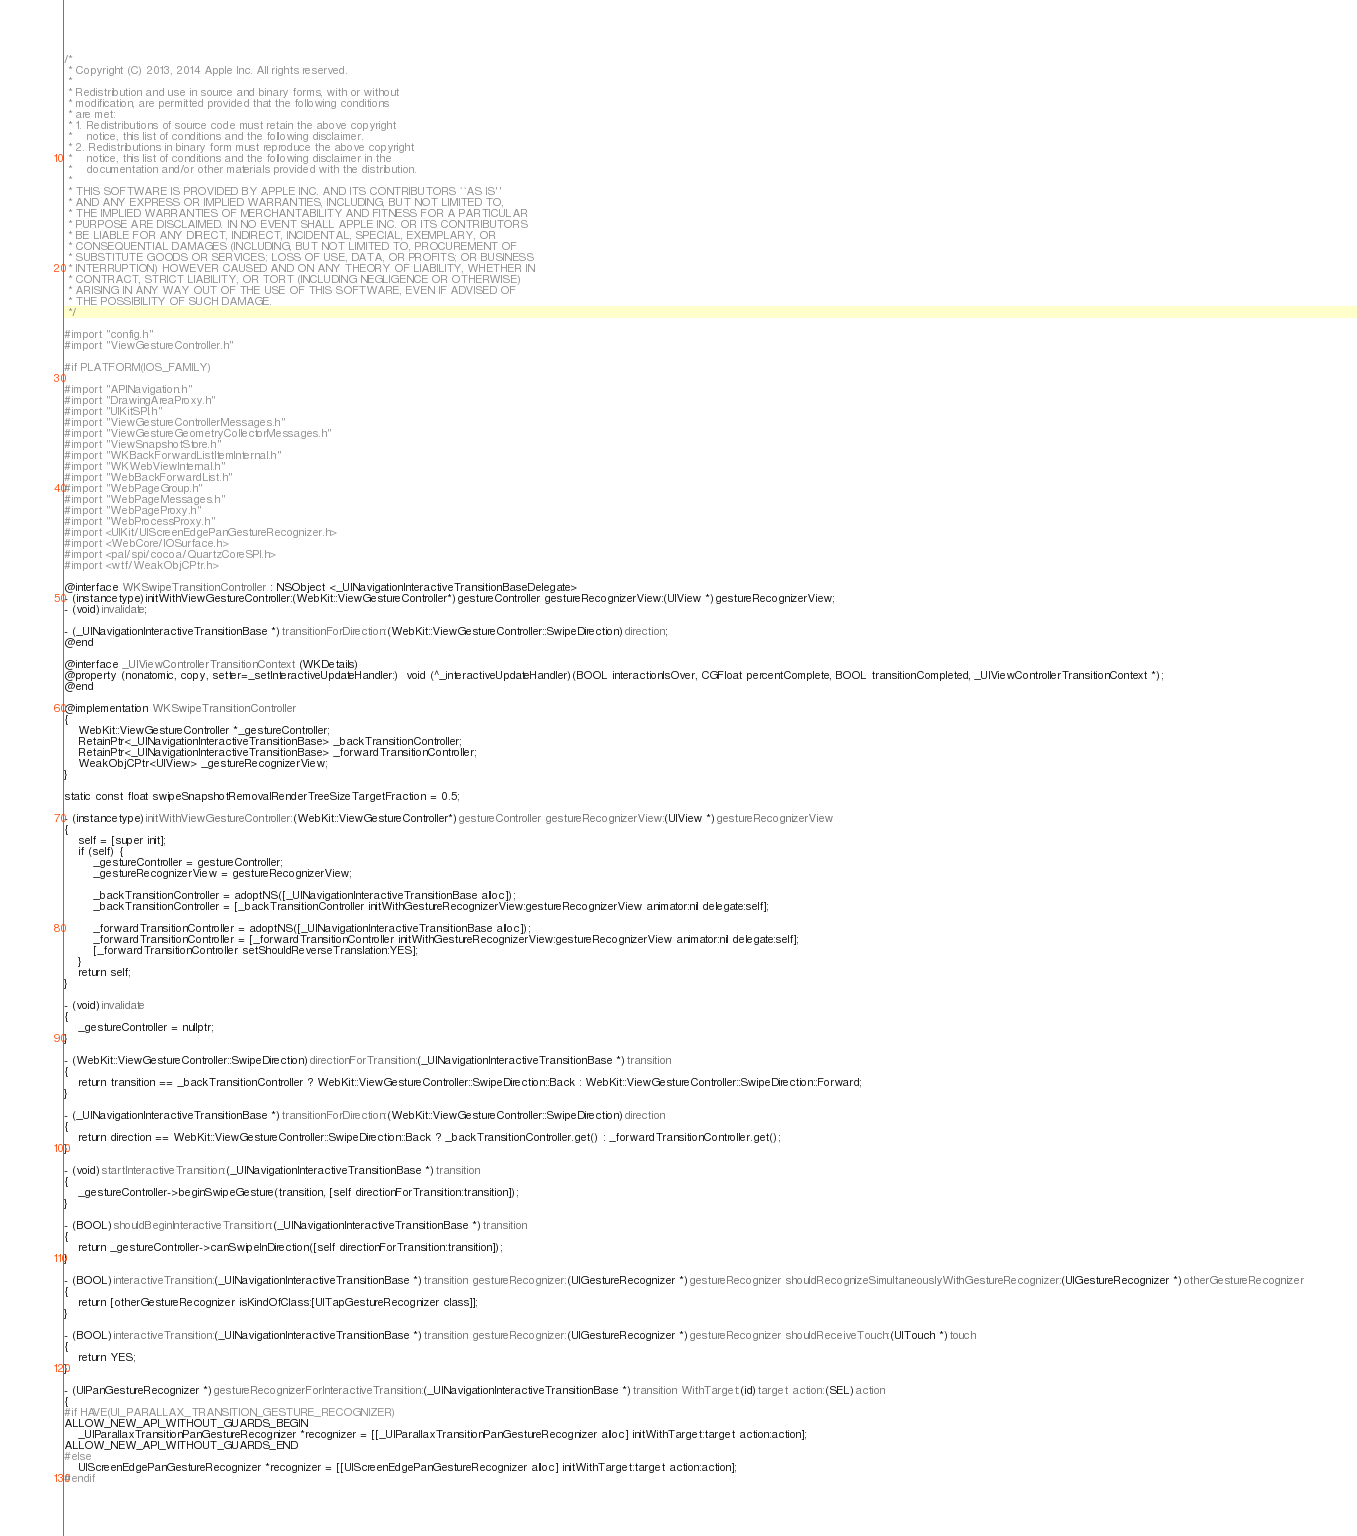<code> <loc_0><loc_0><loc_500><loc_500><_ObjectiveC_>/*
 * Copyright (C) 2013, 2014 Apple Inc. All rights reserved.
 *
 * Redistribution and use in source and binary forms, with or without
 * modification, are permitted provided that the following conditions
 * are met:
 * 1. Redistributions of source code must retain the above copyright
 *    notice, this list of conditions and the following disclaimer.
 * 2. Redistributions in binary form must reproduce the above copyright
 *    notice, this list of conditions and the following disclaimer in the
 *    documentation and/or other materials provided with the distribution.
 *
 * THIS SOFTWARE IS PROVIDED BY APPLE INC. AND ITS CONTRIBUTORS ``AS IS''
 * AND ANY EXPRESS OR IMPLIED WARRANTIES, INCLUDING, BUT NOT LIMITED TO,
 * THE IMPLIED WARRANTIES OF MERCHANTABILITY AND FITNESS FOR A PARTICULAR
 * PURPOSE ARE DISCLAIMED. IN NO EVENT SHALL APPLE INC. OR ITS CONTRIBUTORS
 * BE LIABLE FOR ANY DIRECT, INDIRECT, INCIDENTAL, SPECIAL, EXEMPLARY, OR
 * CONSEQUENTIAL DAMAGES (INCLUDING, BUT NOT LIMITED TO, PROCUREMENT OF
 * SUBSTITUTE GOODS OR SERVICES; LOSS OF USE, DATA, OR PROFITS; OR BUSINESS
 * INTERRUPTION) HOWEVER CAUSED AND ON ANY THEORY OF LIABILITY, WHETHER IN
 * CONTRACT, STRICT LIABILITY, OR TORT (INCLUDING NEGLIGENCE OR OTHERWISE)
 * ARISING IN ANY WAY OUT OF THE USE OF THIS SOFTWARE, EVEN IF ADVISED OF
 * THE POSSIBILITY OF SUCH DAMAGE.
 */

#import "config.h"
#import "ViewGestureController.h"

#if PLATFORM(IOS_FAMILY)

#import "APINavigation.h"
#import "DrawingAreaProxy.h"
#import "UIKitSPI.h"
#import "ViewGestureControllerMessages.h"
#import "ViewGestureGeometryCollectorMessages.h"
#import "ViewSnapshotStore.h"
#import "WKBackForwardListItemInternal.h"
#import "WKWebViewInternal.h"
#import "WebBackForwardList.h"
#import "WebPageGroup.h"
#import "WebPageMessages.h"
#import "WebPageProxy.h"
#import "WebProcessProxy.h"
#import <UIKit/UIScreenEdgePanGestureRecognizer.h>
#import <WebCore/IOSurface.h>
#import <pal/spi/cocoa/QuartzCoreSPI.h>
#import <wtf/WeakObjCPtr.h>

@interface WKSwipeTransitionController : NSObject <_UINavigationInteractiveTransitionBaseDelegate>
- (instancetype)initWithViewGestureController:(WebKit::ViewGestureController*)gestureController gestureRecognizerView:(UIView *)gestureRecognizerView;
- (void)invalidate;

- (_UINavigationInteractiveTransitionBase *)transitionForDirection:(WebKit::ViewGestureController::SwipeDirection)direction;
@end

@interface _UIViewControllerTransitionContext (WKDetails)
@property (nonatomic, copy, setter=_setInteractiveUpdateHandler:)  void (^_interactiveUpdateHandler)(BOOL interactionIsOver, CGFloat percentComplete, BOOL transitionCompleted, _UIViewControllerTransitionContext *);
@end

@implementation WKSwipeTransitionController
{
    WebKit::ViewGestureController *_gestureController;
    RetainPtr<_UINavigationInteractiveTransitionBase> _backTransitionController;
    RetainPtr<_UINavigationInteractiveTransitionBase> _forwardTransitionController;
    WeakObjCPtr<UIView> _gestureRecognizerView;
}

static const float swipeSnapshotRemovalRenderTreeSizeTargetFraction = 0.5;

- (instancetype)initWithViewGestureController:(WebKit::ViewGestureController*)gestureController gestureRecognizerView:(UIView *)gestureRecognizerView
{
    self = [super init];
    if (self) {
        _gestureController = gestureController;
        _gestureRecognizerView = gestureRecognizerView;

        _backTransitionController = adoptNS([_UINavigationInteractiveTransitionBase alloc]);
        _backTransitionController = [_backTransitionController initWithGestureRecognizerView:gestureRecognizerView animator:nil delegate:self];
        
        _forwardTransitionController = adoptNS([_UINavigationInteractiveTransitionBase alloc]);
        _forwardTransitionController = [_forwardTransitionController initWithGestureRecognizerView:gestureRecognizerView animator:nil delegate:self];
        [_forwardTransitionController setShouldReverseTranslation:YES];
    }
    return self;
}

- (void)invalidate
{
    _gestureController = nullptr;
}

- (WebKit::ViewGestureController::SwipeDirection)directionForTransition:(_UINavigationInteractiveTransitionBase *)transition
{
    return transition == _backTransitionController ? WebKit::ViewGestureController::SwipeDirection::Back : WebKit::ViewGestureController::SwipeDirection::Forward;
}

- (_UINavigationInteractiveTransitionBase *)transitionForDirection:(WebKit::ViewGestureController::SwipeDirection)direction
{
    return direction == WebKit::ViewGestureController::SwipeDirection::Back ? _backTransitionController.get() : _forwardTransitionController.get();
}

- (void)startInteractiveTransition:(_UINavigationInteractiveTransitionBase *)transition
{
    _gestureController->beginSwipeGesture(transition, [self directionForTransition:transition]);
}

- (BOOL)shouldBeginInteractiveTransition:(_UINavigationInteractiveTransitionBase *)transition
{
    return _gestureController->canSwipeInDirection([self directionForTransition:transition]);
}

- (BOOL)interactiveTransition:(_UINavigationInteractiveTransitionBase *)transition gestureRecognizer:(UIGestureRecognizer *)gestureRecognizer shouldRecognizeSimultaneouslyWithGestureRecognizer:(UIGestureRecognizer *)otherGestureRecognizer
{
    return [otherGestureRecognizer isKindOfClass:[UITapGestureRecognizer class]];
}

- (BOOL)interactiveTransition:(_UINavigationInteractiveTransitionBase *)transition gestureRecognizer:(UIGestureRecognizer *)gestureRecognizer shouldReceiveTouch:(UITouch *)touch
{
    return YES;
}

- (UIPanGestureRecognizer *)gestureRecognizerForInteractiveTransition:(_UINavigationInteractiveTransitionBase *)transition WithTarget:(id)target action:(SEL)action
{
#if HAVE(UI_PARALLAX_TRANSITION_GESTURE_RECOGNIZER)
ALLOW_NEW_API_WITHOUT_GUARDS_BEGIN
    _UIParallaxTransitionPanGestureRecognizer *recognizer = [[_UIParallaxTransitionPanGestureRecognizer alloc] initWithTarget:target action:action];
ALLOW_NEW_API_WITHOUT_GUARDS_END
#else
    UIScreenEdgePanGestureRecognizer *recognizer = [[UIScreenEdgePanGestureRecognizer alloc] initWithTarget:target action:action];
#endif</code> 